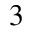<formula> <loc_0><loc_0><loc_500><loc_500>^ { 3 }</formula> 